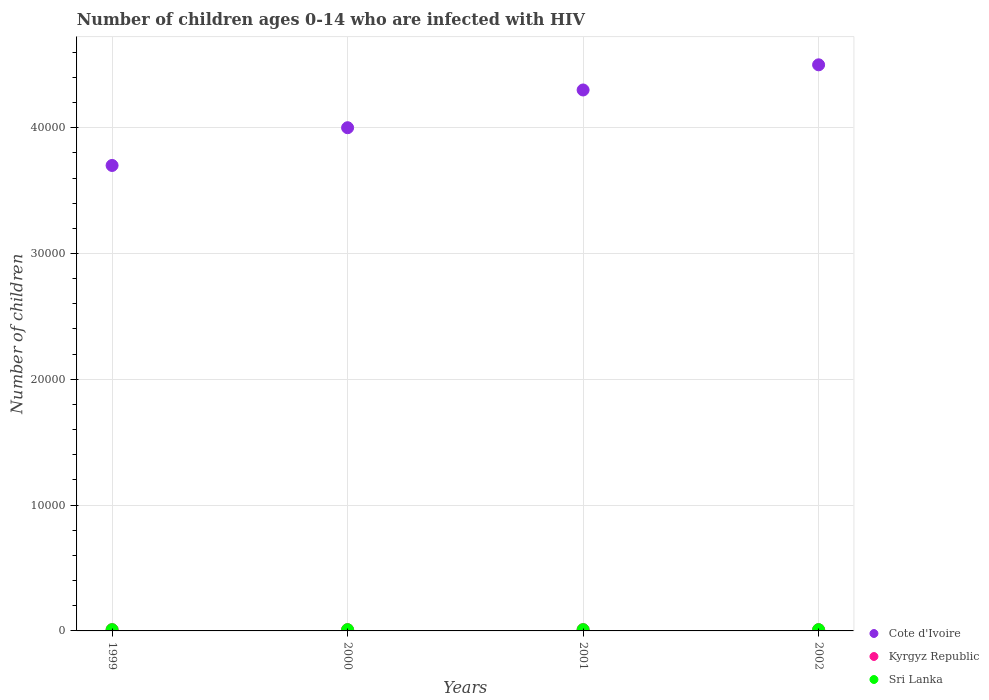Is the number of dotlines equal to the number of legend labels?
Make the answer very short. Yes. What is the number of HIV infected children in Sri Lanka in 2002?
Your answer should be compact. 100. Across all years, what is the maximum number of HIV infected children in Kyrgyz Republic?
Your answer should be compact. 100. Across all years, what is the minimum number of HIV infected children in Sri Lanka?
Offer a very short reply. 100. What is the total number of HIV infected children in Cote d'Ivoire in the graph?
Your answer should be compact. 1.65e+05. What is the difference between the number of HIV infected children in Cote d'Ivoire in 1999 and that in 2002?
Make the answer very short. -8000. What is the difference between the number of HIV infected children in Cote d'Ivoire in 1999 and the number of HIV infected children in Sri Lanka in 2001?
Provide a succinct answer. 3.69e+04. In the year 2000, what is the difference between the number of HIV infected children in Cote d'Ivoire and number of HIV infected children in Sri Lanka?
Your answer should be compact. 3.99e+04. In how many years, is the number of HIV infected children in Cote d'Ivoire greater than 28000?
Offer a very short reply. 4. Is the difference between the number of HIV infected children in Cote d'Ivoire in 2000 and 2002 greater than the difference between the number of HIV infected children in Sri Lanka in 2000 and 2002?
Your answer should be compact. No. What is the difference between the highest and the second highest number of HIV infected children in Cote d'Ivoire?
Offer a terse response. 2000. What is the difference between the highest and the lowest number of HIV infected children in Sri Lanka?
Your answer should be compact. 0. In how many years, is the number of HIV infected children in Kyrgyz Republic greater than the average number of HIV infected children in Kyrgyz Republic taken over all years?
Your answer should be compact. 0. Is the sum of the number of HIV infected children in Kyrgyz Republic in 2001 and 2002 greater than the maximum number of HIV infected children in Sri Lanka across all years?
Provide a succinct answer. Yes. Is it the case that in every year, the sum of the number of HIV infected children in Kyrgyz Republic and number of HIV infected children in Cote d'Ivoire  is greater than the number of HIV infected children in Sri Lanka?
Keep it short and to the point. Yes. Is the number of HIV infected children in Kyrgyz Republic strictly greater than the number of HIV infected children in Cote d'Ivoire over the years?
Provide a short and direct response. No. Is the number of HIV infected children in Kyrgyz Republic strictly less than the number of HIV infected children in Sri Lanka over the years?
Your answer should be very brief. No. How many dotlines are there?
Offer a terse response. 3. Are the values on the major ticks of Y-axis written in scientific E-notation?
Give a very brief answer. No. Does the graph contain any zero values?
Ensure brevity in your answer.  No. Where does the legend appear in the graph?
Your response must be concise. Bottom right. How many legend labels are there?
Make the answer very short. 3. What is the title of the graph?
Your answer should be very brief. Number of children ages 0-14 who are infected with HIV. What is the label or title of the X-axis?
Provide a short and direct response. Years. What is the label or title of the Y-axis?
Provide a short and direct response. Number of children. What is the Number of children of Cote d'Ivoire in 1999?
Provide a succinct answer. 3.70e+04. What is the Number of children in Kyrgyz Republic in 1999?
Make the answer very short. 100. What is the Number of children in Sri Lanka in 1999?
Your response must be concise. 100. What is the Number of children of Cote d'Ivoire in 2000?
Ensure brevity in your answer.  4.00e+04. What is the Number of children in Cote d'Ivoire in 2001?
Ensure brevity in your answer.  4.30e+04. What is the Number of children in Cote d'Ivoire in 2002?
Give a very brief answer. 4.50e+04. What is the Number of children in Sri Lanka in 2002?
Offer a very short reply. 100. Across all years, what is the maximum Number of children in Cote d'Ivoire?
Make the answer very short. 4.50e+04. Across all years, what is the maximum Number of children in Sri Lanka?
Offer a terse response. 100. Across all years, what is the minimum Number of children of Cote d'Ivoire?
Provide a succinct answer. 3.70e+04. Across all years, what is the minimum Number of children in Kyrgyz Republic?
Your response must be concise. 100. What is the total Number of children of Cote d'Ivoire in the graph?
Your answer should be very brief. 1.65e+05. What is the difference between the Number of children of Cote d'Ivoire in 1999 and that in 2000?
Offer a very short reply. -3000. What is the difference between the Number of children in Kyrgyz Republic in 1999 and that in 2000?
Provide a short and direct response. 0. What is the difference between the Number of children in Cote d'Ivoire in 1999 and that in 2001?
Give a very brief answer. -6000. What is the difference between the Number of children in Cote d'Ivoire in 1999 and that in 2002?
Your answer should be very brief. -8000. What is the difference between the Number of children in Kyrgyz Republic in 1999 and that in 2002?
Offer a terse response. 0. What is the difference between the Number of children in Sri Lanka in 1999 and that in 2002?
Your answer should be compact. 0. What is the difference between the Number of children in Cote d'Ivoire in 2000 and that in 2001?
Your response must be concise. -3000. What is the difference between the Number of children in Kyrgyz Republic in 2000 and that in 2001?
Provide a short and direct response. 0. What is the difference between the Number of children in Sri Lanka in 2000 and that in 2001?
Offer a terse response. 0. What is the difference between the Number of children in Cote d'Ivoire in 2000 and that in 2002?
Your answer should be compact. -5000. What is the difference between the Number of children in Kyrgyz Republic in 2000 and that in 2002?
Provide a short and direct response. 0. What is the difference between the Number of children in Cote d'Ivoire in 2001 and that in 2002?
Offer a terse response. -2000. What is the difference between the Number of children of Cote d'Ivoire in 1999 and the Number of children of Kyrgyz Republic in 2000?
Make the answer very short. 3.69e+04. What is the difference between the Number of children in Cote d'Ivoire in 1999 and the Number of children in Sri Lanka in 2000?
Make the answer very short. 3.69e+04. What is the difference between the Number of children in Kyrgyz Republic in 1999 and the Number of children in Sri Lanka in 2000?
Ensure brevity in your answer.  0. What is the difference between the Number of children of Cote d'Ivoire in 1999 and the Number of children of Kyrgyz Republic in 2001?
Ensure brevity in your answer.  3.69e+04. What is the difference between the Number of children of Cote d'Ivoire in 1999 and the Number of children of Sri Lanka in 2001?
Offer a terse response. 3.69e+04. What is the difference between the Number of children in Kyrgyz Republic in 1999 and the Number of children in Sri Lanka in 2001?
Offer a terse response. 0. What is the difference between the Number of children in Cote d'Ivoire in 1999 and the Number of children in Kyrgyz Republic in 2002?
Your answer should be compact. 3.69e+04. What is the difference between the Number of children in Cote d'Ivoire in 1999 and the Number of children in Sri Lanka in 2002?
Offer a terse response. 3.69e+04. What is the difference between the Number of children in Cote d'Ivoire in 2000 and the Number of children in Kyrgyz Republic in 2001?
Ensure brevity in your answer.  3.99e+04. What is the difference between the Number of children in Cote d'Ivoire in 2000 and the Number of children in Sri Lanka in 2001?
Your answer should be compact. 3.99e+04. What is the difference between the Number of children of Kyrgyz Republic in 2000 and the Number of children of Sri Lanka in 2001?
Keep it short and to the point. 0. What is the difference between the Number of children of Cote d'Ivoire in 2000 and the Number of children of Kyrgyz Republic in 2002?
Your answer should be very brief. 3.99e+04. What is the difference between the Number of children in Cote d'Ivoire in 2000 and the Number of children in Sri Lanka in 2002?
Provide a succinct answer. 3.99e+04. What is the difference between the Number of children in Cote d'Ivoire in 2001 and the Number of children in Kyrgyz Republic in 2002?
Your answer should be very brief. 4.29e+04. What is the difference between the Number of children of Cote d'Ivoire in 2001 and the Number of children of Sri Lanka in 2002?
Ensure brevity in your answer.  4.29e+04. What is the difference between the Number of children of Kyrgyz Republic in 2001 and the Number of children of Sri Lanka in 2002?
Make the answer very short. 0. What is the average Number of children in Cote d'Ivoire per year?
Make the answer very short. 4.12e+04. In the year 1999, what is the difference between the Number of children in Cote d'Ivoire and Number of children in Kyrgyz Republic?
Ensure brevity in your answer.  3.69e+04. In the year 1999, what is the difference between the Number of children of Cote d'Ivoire and Number of children of Sri Lanka?
Keep it short and to the point. 3.69e+04. In the year 2000, what is the difference between the Number of children of Cote d'Ivoire and Number of children of Kyrgyz Republic?
Offer a terse response. 3.99e+04. In the year 2000, what is the difference between the Number of children of Cote d'Ivoire and Number of children of Sri Lanka?
Your response must be concise. 3.99e+04. In the year 2000, what is the difference between the Number of children of Kyrgyz Republic and Number of children of Sri Lanka?
Give a very brief answer. 0. In the year 2001, what is the difference between the Number of children of Cote d'Ivoire and Number of children of Kyrgyz Republic?
Your response must be concise. 4.29e+04. In the year 2001, what is the difference between the Number of children of Cote d'Ivoire and Number of children of Sri Lanka?
Offer a terse response. 4.29e+04. In the year 2002, what is the difference between the Number of children of Cote d'Ivoire and Number of children of Kyrgyz Republic?
Your response must be concise. 4.49e+04. In the year 2002, what is the difference between the Number of children in Cote d'Ivoire and Number of children in Sri Lanka?
Offer a terse response. 4.49e+04. What is the ratio of the Number of children of Cote d'Ivoire in 1999 to that in 2000?
Keep it short and to the point. 0.93. What is the ratio of the Number of children in Kyrgyz Republic in 1999 to that in 2000?
Offer a very short reply. 1. What is the ratio of the Number of children in Sri Lanka in 1999 to that in 2000?
Your answer should be compact. 1. What is the ratio of the Number of children of Cote d'Ivoire in 1999 to that in 2001?
Provide a succinct answer. 0.86. What is the ratio of the Number of children in Kyrgyz Republic in 1999 to that in 2001?
Provide a short and direct response. 1. What is the ratio of the Number of children of Sri Lanka in 1999 to that in 2001?
Your answer should be compact. 1. What is the ratio of the Number of children in Cote d'Ivoire in 1999 to that in 2002?
Give a very brief answer. 0.82. What is the ratio of the Number of children in Kyrgyz Republic in 1999 to that in 2002?
Make the answer very short. 1. What is the ratio of the Number of children in Cote d'Ivoire in 2000 to that in 2001?
Ensure brevity in your answer.  0.93. What is the ratio of the Number of children in Sri Lanka in 2000 to that in 2002?
Your answer should be compact. 1. What is the ratio of the Number of children of Cote d'Ivoire in 2001 to that in 2002?
Give a very brief answer. 0.96. What is the ratio of the Number of children in Sri Lanka in 2001 to that in 2002?
Offer a very short reply. 1. What is the difference between the highest and the second highest Number of children in Kyrgyz Republic?
Your response must be concise. 0. What is the difference between the highest and the lowest Number of children in Cote d'Ivoire?
Ensure brevity in your answer.  8000. 